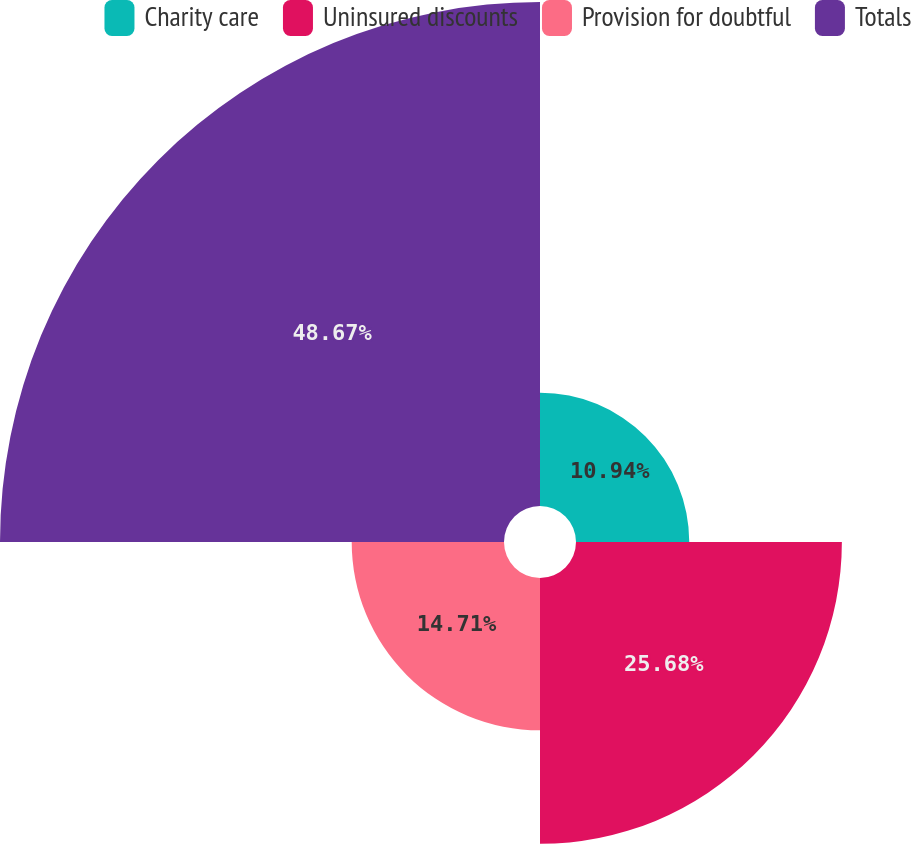<chart> <loc_0><loc_0><loc_500><loc_500><pie_chart><fcel>Charity care<fcel>Uninsured discounts<fcel>Provision for doubtful<fcel>Totals<nl><fcel>10.94%<fcel>25.68%<fcel>14.71%<fcel>48.68%<nl></chart> 